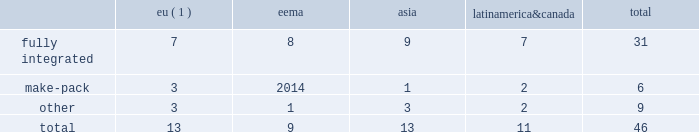2022 the failure of our information systems to function as intended or their penetration by outside parties with the intent to corrupt them or our failure to comply with privacy laws and regulations could result in business disruption , litigation and regulatory action , and loss of revenue , assets or personal or other confidential data .
We use information systems to help manage business processes , collect and interpret business data and communicate internally and externally with employees , suppliers , customers and others .
Some of these information systems are managed by third-party service providers .
We have backup systems and business continuity plans in place , and we take care to protect our systems and data from unauthorized access .
Nevertheless , failure of our systems to function as intended , or penetration of our systems by outside parties intent on extracting or corrupting information or otherwise disrupting business processes , could place us at a competitive disadvantage , result in a loss of revenue , assets or personal or other sensitive data , litigation and regulatory action , cause damage to our reputation and that of our brands and result in significant remediation and other costs .
Failure to protect personal data and respect the rights of data subjects could subject us to substantial fines under regulations such as the eu general data protection regulation .
2022 we may be required to replace third-party contract manufacturers or service providers with our own resources .
In certain instances , we contract with third parties to manufacture some of our products or product parts or to provide other services .
We may be unable to renew these agreements on satisfactory terms for numerous reasons , including government regulations .
Accordingly , our costs may increase significantly if we must replace such third parties with our own resources .
Item 1b .
Unresolved staff comments .
Item 2 .
Properties .
At december 31 , 2017 , we operated and owned 46 manufacturing facilities and maintained contract manufacturing relationships with 25 third-party manufacturers across 23 markets .
In addition , we work with 38 third-party operators in indonesia who manufacture our hand-rolled cigarettes .
Pmi-owned manufacturing facilities eema asia america canada total .
( 1 ) includes facilities that produced heated tobacco units in 2017 .
In 2017 , 23 of our facilities each manufactured over 10 billion cigarettes , of which eight facilities each produced over 30 billion units .
Our largest factories are in karawang and sukorejo ( indonesia ) , izmir ( turkey ) , krakow ( poland ) , st .
Petersburg and krasnodar ( russia ) , batangas and marikina ( philippines ) , berlin ( germany ) , kharkiv ( ukraine ) , and kutna hora ( czech republic ) .
Our smallest factories are mostly in latin america and asia , where due to tariff and other constraints we have established small manufacturing units in individual markets .
We will continue to optimize our manufacturing base , taking into consideration the evolution of trade blocks .
The plants and properties owned or leased and operated by our subsidiaries are maintained in good condition and are believed to be suitable and adequate for our present needs .
We are integrating the production of heated tobacco units into a number of our existing manufacturing facilities and progressing with our plans to build manufacturing capacity for our other rrp platforms. .
What portion of total facilities are located in eu? 
Computations: (13 / 46)
Answer: 0.28261. 